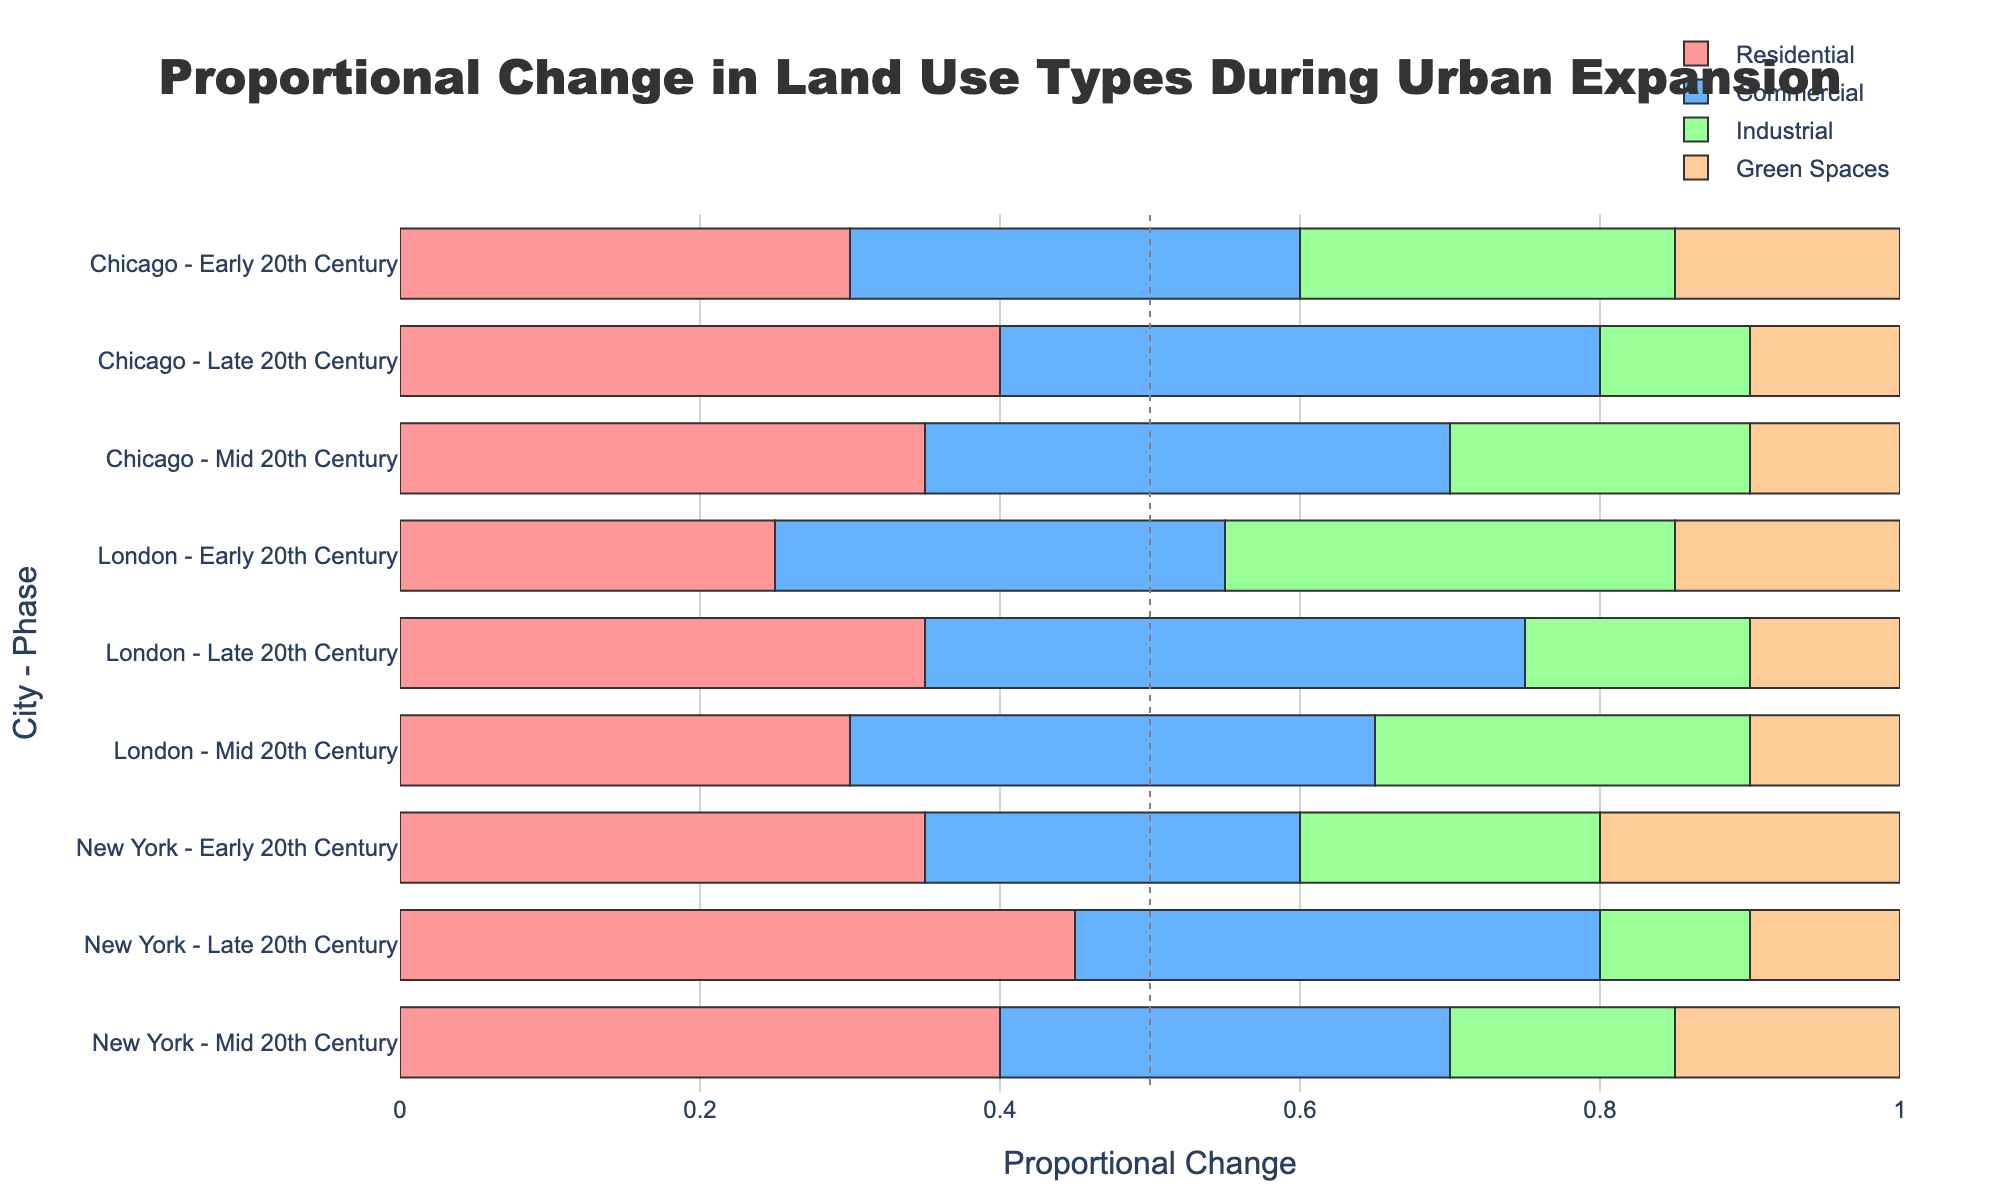What is the total proportional change for residential land use in New York during the Late 20th Century? The total proportional change for residential land use in New York during the Late 20th Century can be directly read from the figure. Look for the bar segment labeled "Residential" corresponding to "New York - Late 20th Century".
Answer: 0.45 How does the proportional change for commercial land use in Chicago during the Early 20th Century compare to London's during the same period? To find the answer, check the bar segments labeled "Commercial" for both "Chicago - Early 20th Century" and "London - Early 20th Century". Compare their lengths and hover text.
Answer: Chicago: 0.30, London: 0.30 What is the sum of the proportional changes for green spaces in all phases for New York? Sum the proportional changes of green spaces in New York across the Early, Mid, and Late 20th Century phases by locating their respective segments.
Answer: 0.20 + 0.15 + 0.10 = 0.45 Which city has the highest proportional change for industrial land use in the Mid 20th Century? Compare the segments labeled "Industrial" for New York, Chicago, and London in the Mid 20th Century. Check the lengths and hover text.
Answer: London By how much did the proportional change for residential land use in New York increase from the Early to Late 20th Century? Find the proportional changes for residential land use in the Early and Late 20th Century for New York. Subtract the earlier value from the later value.
Answer: 0.45 - 0.35 = 0.10 In the Early 20th Century, which land use type has the smallest proportional change in Chicago, and what is its value? Look for the shortest bar segment in the "Chicago - Early 20th Century" portion of the figure.
Answer: Green Spaces: 0.15 What is the average proportional change for commercial land use across all cities in the Late 20th Century? Calculate the average by summing the proportional changes for commercial land use in New York, Chicago, and London for the Late 20th Century and dividing by 3.
Answer: (0.35 + 0.40 + 0.40) / 3 = 0.38333 Is the proportional change for green spaces in the Mid 20th Century higher in New York or Chicago? Compare the lengths of the bar segments labeled "Green Spaces" for New York and Chicago in the Mid 20th Century.
Answer: New York: 0.15, Chicago: 0.10 Which city shows the greatest decline in the proportional change for industrial land use from the Early to Late 20th Century? Calculate the difference in proportional change for industrial land use from the Early to Late 20th Century for each city and compare.
Answer: New York 